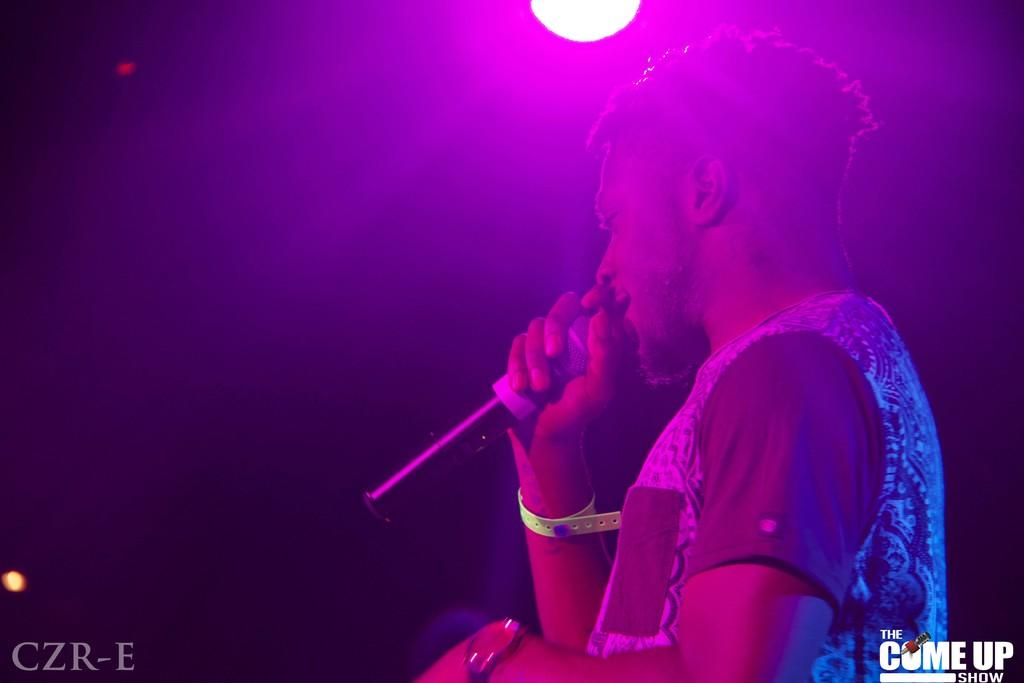What is the main subject of the image? There is a person in the image. What is the person holding in the image? The person is holding a microphone. What color is the light in the background of the image? There is purple-colored light in the background of the image. What type of toothpaste is the person using in the image? There is no toothpaste present in the image. What meal is the person eating while holding the microphone in the image? There is no meal present in the image, and the person is not eating. 